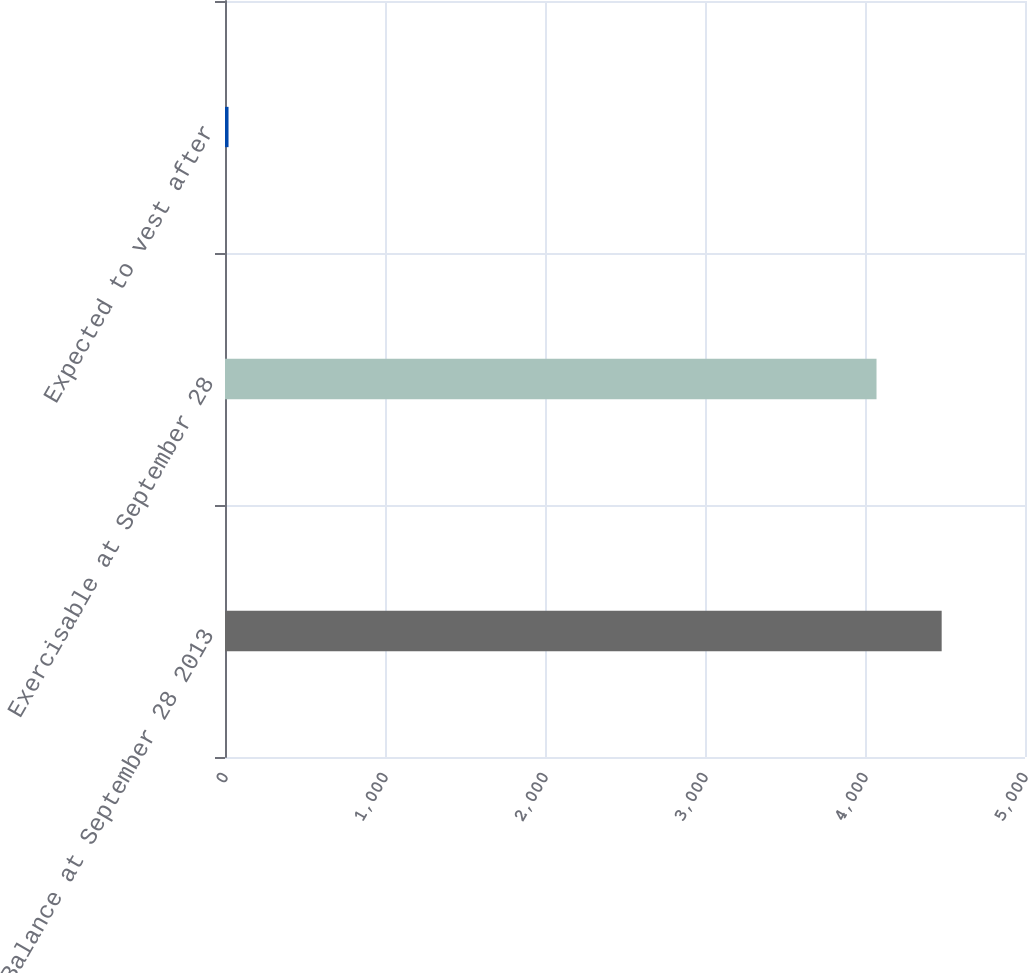<chart> <loc_0><loc_0><loc_500><loc_500><bar_chart><fcel>Balance at September 28 2013<fcel>Exercisable at September 28<fcel>Expected to vest after<nl><fcel>4479.2<fcel>4072<fcel>22<nl></chart> 